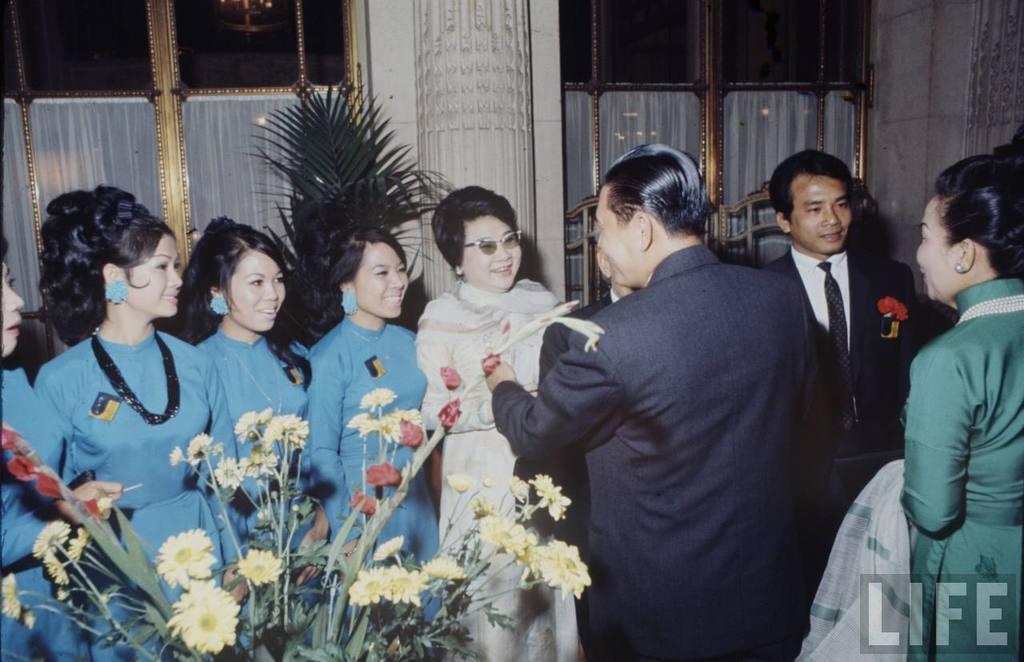Could you give a brief overview of what you see in this image? In this picture we can see a group of people standing, smiling and in front of them we can see flowers and in the background we can see leaves, pillar, wall, windows with curtains and some objects. 